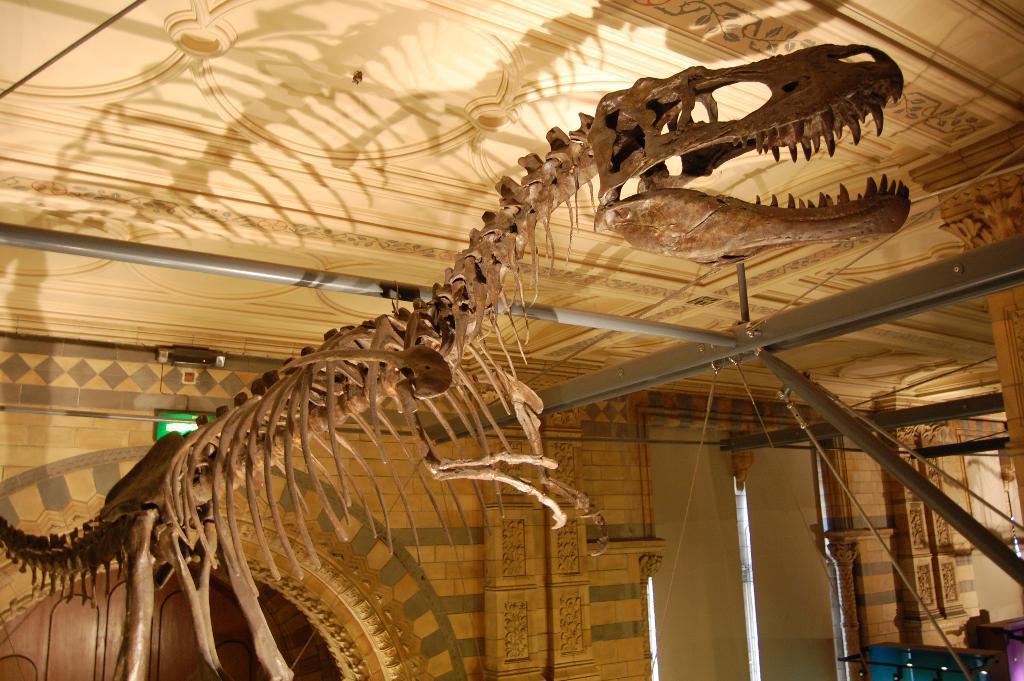Please provide a concise description of this image. In this image we can see the skeleton of an animal under a roof. We can also a door, some metal poles, wires, a board and a wall. 